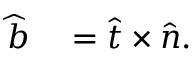Convert formula to latex. <formula><loc_0><loc_0><loc_500><loc_500>\begin{array} { r l } { \widehat { b } } & = \widehat { t } \times \widehat { n } . } \end{array}</formula> 